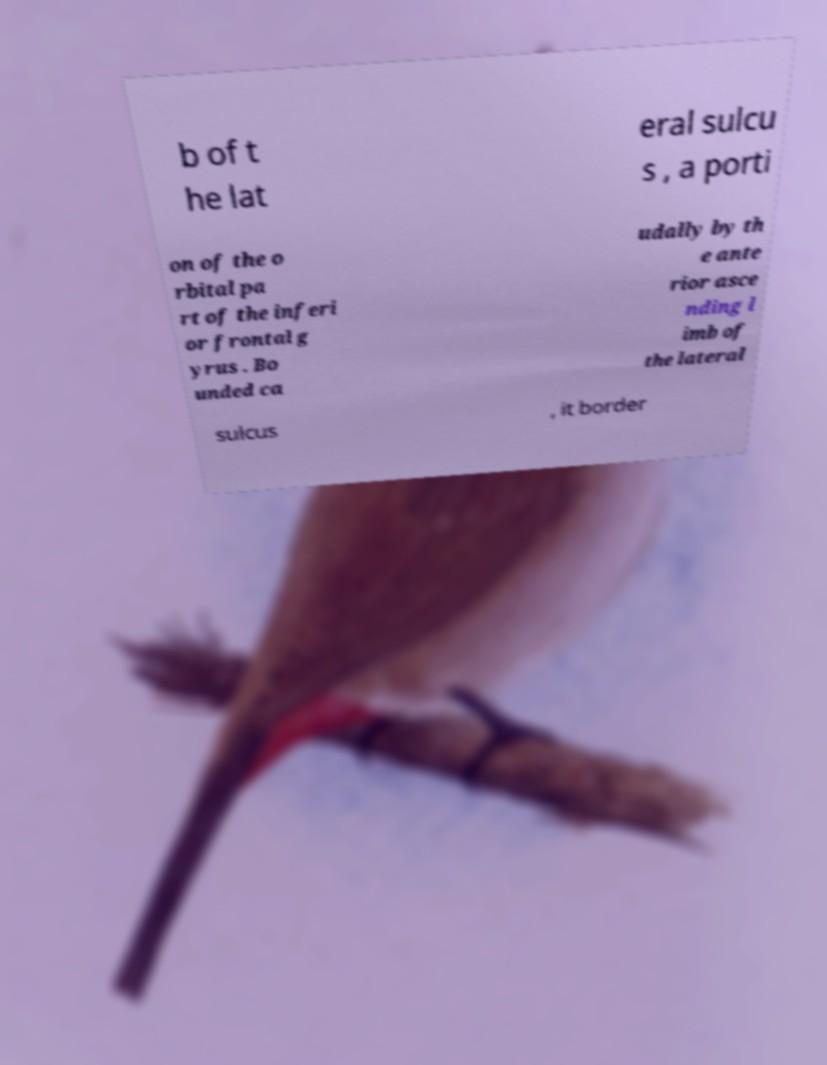I need the written content from this picture converted into text. Can you do that? b of t he lat eral sulcu s , a porti on of the o rbital pa rt of the inferi or frontal g yrus . Bo unded ca udally by th e ante rior asce nding l imb of the lateral sulcus , it border 